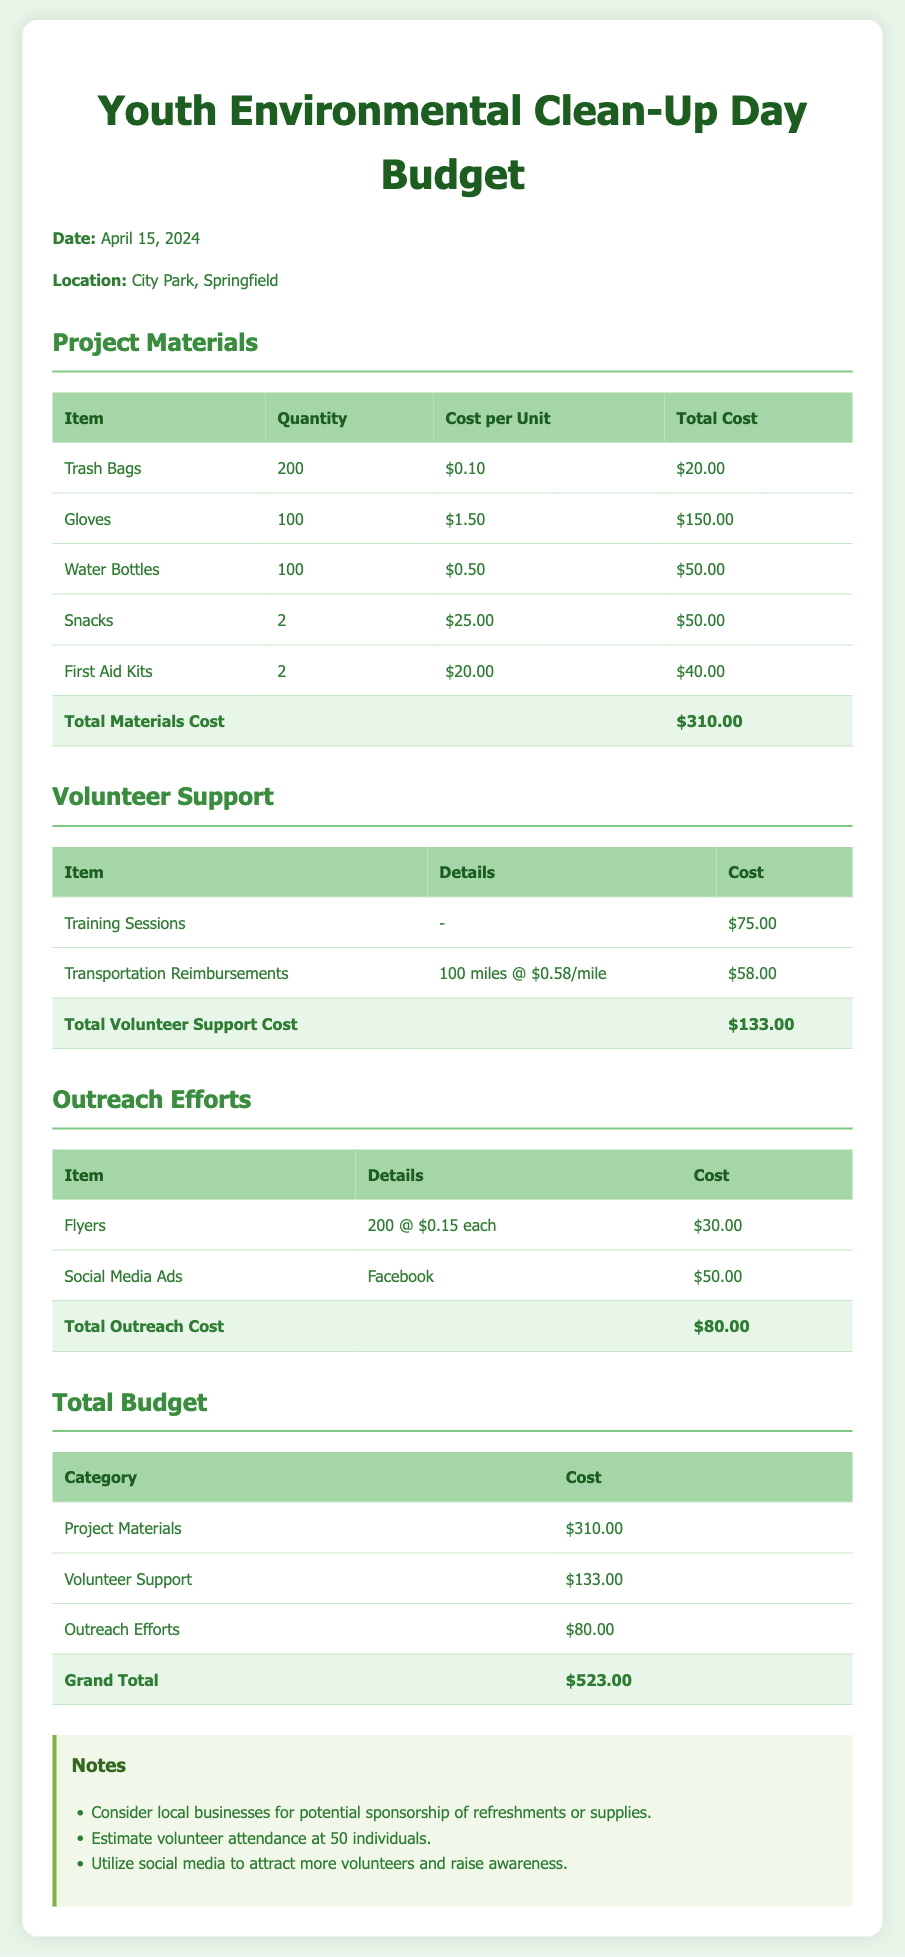what is the total materials cost? The total materials cost is the sum of all item costs listed under project materials, which is $310.00.
Answer: $310.00 what is the cost for training sessions? The document lists the cost for training sessions under volunteer support as $75.00.
Answer: $75.00 how many trash bags are needed? The number of trash bags required is shown in the project materials section as 200.
Answer: 200 what is the total outreach cost? The total outreach cost is calculated from the costs detailed under outreach efforts, which is $80.00.
Answer: $80.00 what is the grand total budget? The grand total budget is summarized in the total budget section, which amounts to $523.00.
Answer: $523.00 how many volunteers are estimated to attend? The estimated number of volunteers attending, mentioned in the notes, is 50 individuals.
Answer: 50 individuals what is the cost per mile for transportation reimbursement? The cost per mile for transportation reimbursement is stated in volunteer support as $0.58/mile.
Answer: $0.58/mile how many water bottles are included in the project materials? The documentation specifies that 100 water bottles are included in the project materials.
Answer: 100 what items are mentioned under outreach efforts? The items listed under outreach efforts are flyers and social media ads.
Answer: flyers, social media ads 